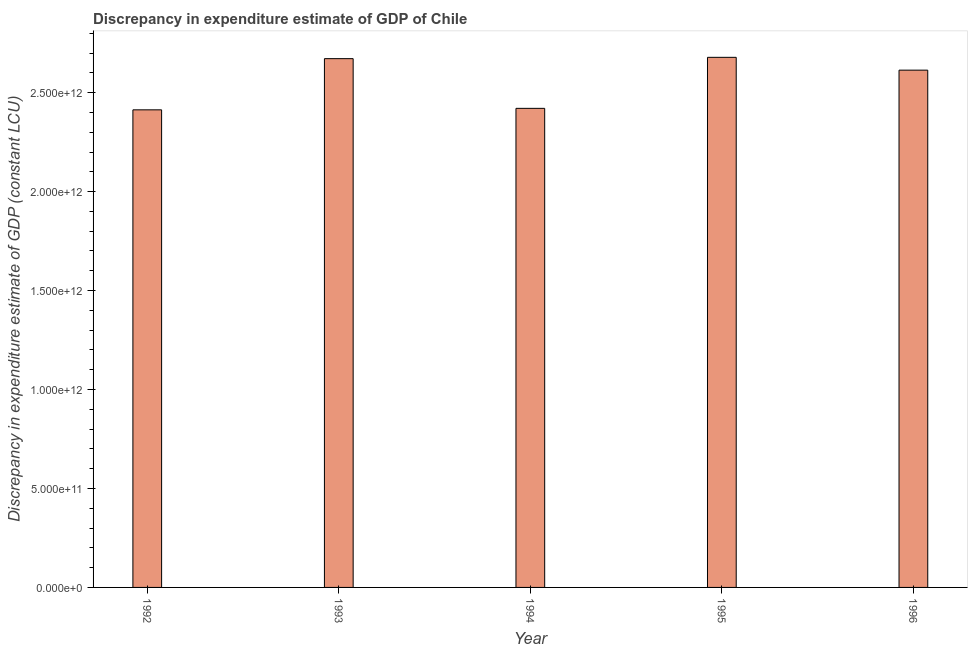Does the graph contain grids?
Make the answer very short. No. What is the title of the graph?
Your response must be concise. Discrepancy in expenditure estimate of GDP of Chile. What is the label or title of the X-axis?
Give a very brief answer. Year. What is the label or title of the Y-axis?
Provide a succinct answer. Discrepancy in expenditure estimate of GDP (constant LCU). What is the discrepancy in expenditure estimate of gdp in 1995?
Offer a very short reply. 2.68e+12. Across all years, what is the maximum discrepancy in expenditure estimate of gdp?
Make the answer very short. 2.68e+12. Across all years, what is the minimum discrepancy in expenditure estimate of gdp?
Provide a short and direct response. 2.41e+12. In which year was the discrepancy in expenditure estimate of gdp minimum?
Give a very brief answer. 1992. What is the sum of the discrepancy in expenditure estimate of gdp?
Your answer should be compact. 1.28e+13. What is the difference between the discrepancy in expenditure estimate of gdp in 1992 and 1996?
Your answer should be very brief. -2.01e+11. What is the average discrepancy in expenditure estimate of gdp per year?
Give a very brief answer. 2.56e+12. What is the median discrepancy in expenditure estimate of gdp?
Ensure brevity in your answer.  2.61e+12. In how many years, is the discrepancy in expenditure estimate of gdp greater than 600000000000 LCU?
Your response must be concise. 5. What is the ratio of the discrepancy in expenditure estimate of gdp in 1994 to that in 1996?
Keep it short and to the point. 0.93. Is the discrepancy in expenditure estimate of gdp in 1993 less than that in 1995?
Offer a terse response. Yes. What is the difference between the highest and the second highest discrepancy in expenditure estimate of gdp?
Your response must be concise. 6.68e+09. Is the sum of the discrepancy in expenditure estimate of gdp in 1993 and 1995 greater than the maximum discrepancy in expenditure estimate of gdp across all years?
Provide a short and direct response. Yes. What is the difference between the highest and the lowest discrepancy in expenditure estimate of gdp?
Give a very brief answer. 2.65e+11. What is the difference between two consecutive major ticks on the Y-axis?
Offer a very short reply. 5.00e+11. Are the values on the major ticks of Y-axis written in scientific E-notation?
Your response must be concise. Yes. What is the Discrepancy in expenditure estimate of GDP (constant LCU) in 1992?
Offer a very short reply. 2.41e+12. What is the Discrepancy in expenditure estimate of GDP (constant LCU) of 1993?
Offer a terse response. 2.67e+12. What is the Discrepancy in expenditure estimate of GDP (constant LCU) of 1994?
Ensure brevity in your answer.  2.42e+12. What is the Discrepancy in expenditure estimate of GDP (constant LCU) of 1995?
Provide a short and direct response. 2.68e+12. What is the Discrepancy in expenditure estimate of GDP (constant LCU) in 1996?
Make the answer very short. 2.61e+12. What is the difference between the Discrepancy in expenditure estimate of GDP (constant LCU) in 1992 and 1993?
Make the answer very short. -2.59e+11. What is the difference between the Discrepancy in expenditure estimate of GDP (constant LCU) in 1992 and 1994?
Provide a succinct answer. -7.47e+09. What is the difference between the Discrepancy in expenditure estimate of GDP (constant LCU) in 1992 and 1995?
Keep it short and to the point. -2.65e+11. What is the difference between the Discrepancy in expenditure estimate of GDP (constant LCU) in 1992 and 1996?
Provide a short and direct response. -2.01e+11. What is the difference between the Discrepancy in expenditure estimate of GDP (constant LCU) in 1993 and 1994?
Keep it short and to the point. 2.51e+11. What is the difference between the Discrepancy in expenditure estimate of GDP (constant LCU) in 1993 and 1995?
Ensure brevity in your answer.  -6.68e+09. What is the difference between the Discrepancy in expenditure estimate of GDP (constant LCU) in 1993 and 1996?
Offer a terse response. 5.81e+1. What is the difference between the Discrepancy in expenditure estimate of GDP (constant LCU) in 1994 and 1995?
Ensure brevity in your answer.  -2.58e+11. What is the difference between the Discrepancy in expenditure estimate of GDP (constant LCU) in 1994 and 1996?
Offer a very short reply. -1.93e+11. What is the difference between the Discrepancy in expenditure estimate of GDP (constant LCU) in 1995 and 1996?
Your answer should be compact. 6.48e+1. What is the ratio of the Discrepancy in expenditure estimate of GDP (constant LCU) in 1992 to that in 1993?
Make the answer very short. 0.9. What is the ratio of the Discrepancy in expenditure estimate of GDP (constant LCU) in 1992 to that in 1994?
Give a very brief answer. 1. What is the ratio of the Discrepancy in expenditure estimate of GDP (constant LCU) in 1992 to that in 1995?
Your response must be concise. 0.9. What is the ratio of the Discrepancy in expenditure estimate of GDP (constant LCU) in 1992 to that in 1996?
Provide a short and direct response. 0.92. What is the ratio of the Discrepancy in expenditure estimate of GDP (constant LCU) in 1993 to that in 1994?
Provide a short and direct response. 1.1. What is the ratio of the Discrepancy in expenditure estimate of GDP (constant LCU) in 1993 to that in 1995?
Your response must be concise. 1. What is the ratio of the Discrepancy in expenditure estimate of GDP (constant LCU) in 1994 to that in 1995?
Offer a very short reply. 0.9. What is the ratio of the Discrepancy in expenditure estimate of GDP (constant LCU) in 1994 to that in 1996?
Give a very brief answer. 0.93. What is the ratio of the Discrepancy in expenditure estimate of GDP (constant LCU) in 1995 to that in 1996?
Provide a succinct answer. 1.02. 